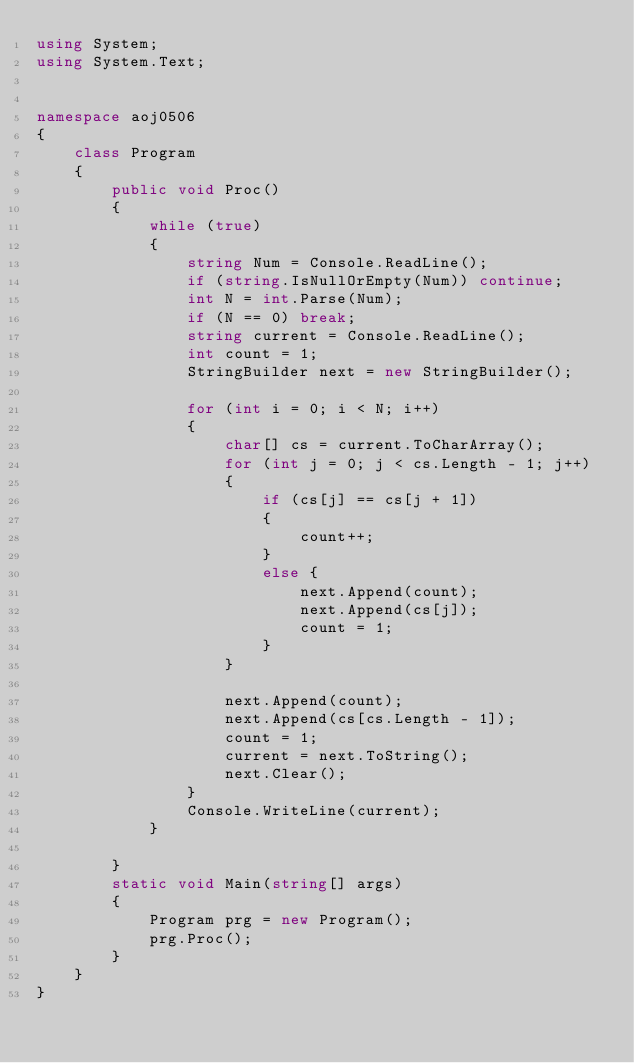Convert code to text. <code><loc_0><loc_0><loc_500><loc_500><_C#_>using System;
using System.Text;


namespace aoj0506
{
    class Program
    {
        public void Proc()
        {
            while (true)
            {
                string Num = Console.ReadLine();
                if (string.IsNullOrEmpty(Num)) continue;
                int N = int.Parse(Num);
                if (N == 0) break;
                string current = Console.ReadLine();
                int count = 1;
                StringBuilder next = new StringBuilder();

                for (int i = 0; i < N; i++)
                {
                    char[] cs = current.ToCharArray();
                    for (int j = 0; j < cs.Length - 1; j++)
                    {
                        if (cs[j] == cs[j + 1])
                        {
                            count++;
                        }
                        else {
                            next.Append(count);
                            next.Append(cs[j]);              
                            count = 1;
                        }
                    }

                    next.Append(count);
                    next.Append(cs[cs.Length - 1]);
                    count = 1;
                    current = next.ToString();
                    next.Clear();
                }
                Console.WriteLine(current);
            }

        }
        static void Main(string[] args)
        {
            Program prg = new Program();
            prg.Proc();
        }
    }
}</code> 